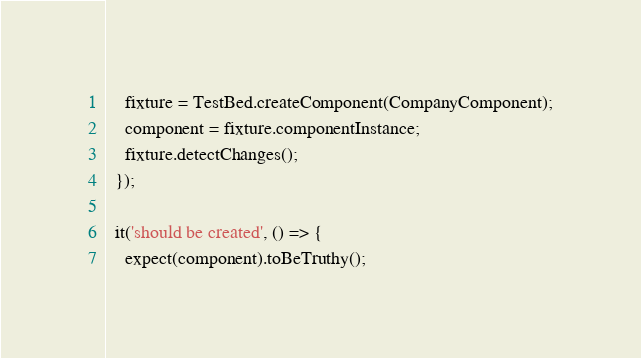<code> <loc_0><loc_0><loc_500><loc_500><_TypeScript_>    fixture = TestBed.createComponent(CompanyComponent);
    component = fixture.componentInstance;
    fixture.detectChanges();
  });

  it('should be created', () => {
    expect(component).toBeTruthy();</code> 